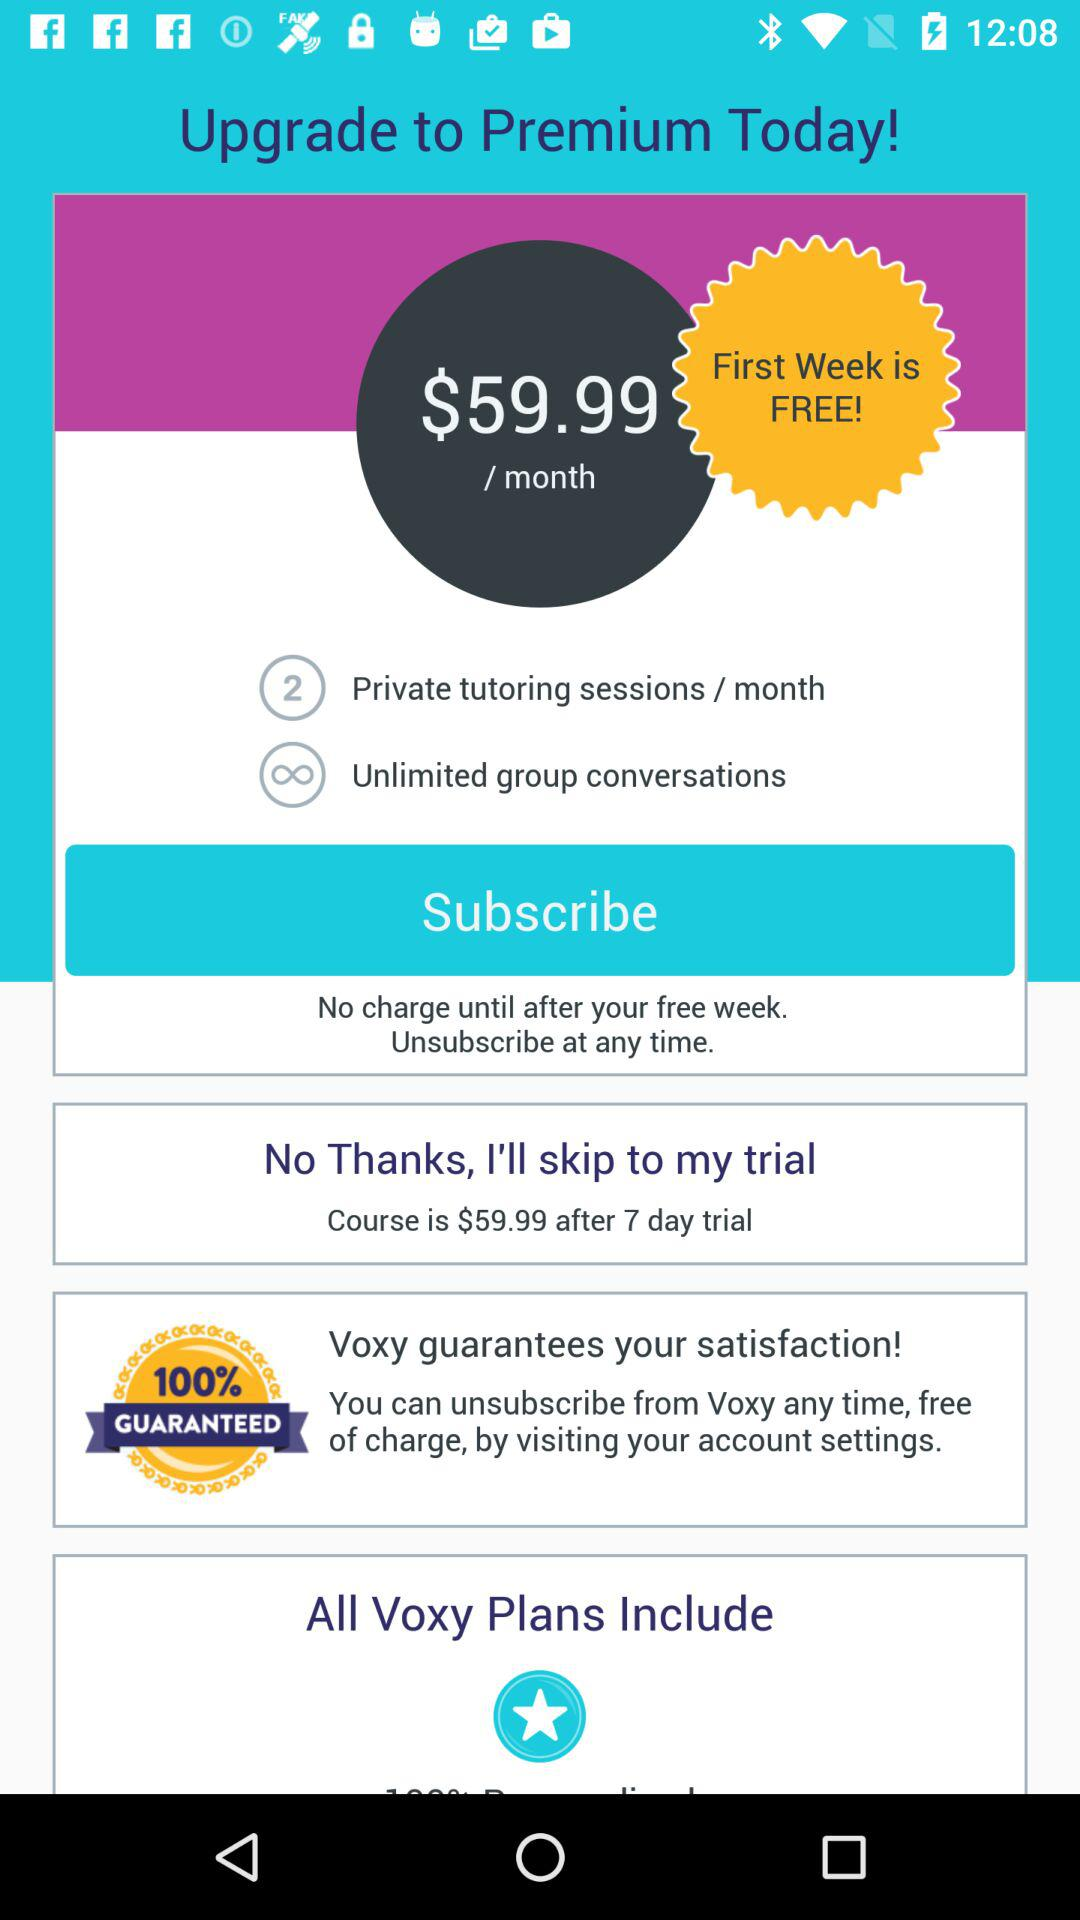How many private tutoring sessions per month are included in the premium plan?
Answer the question using a single word or phrase. 2 